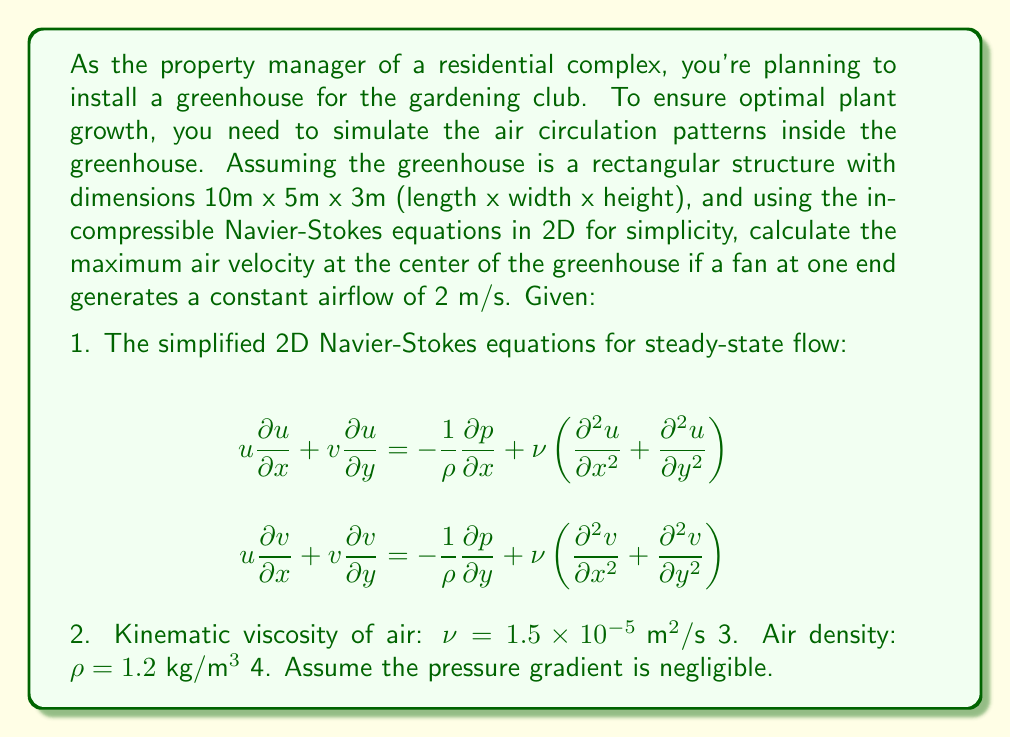What is the answer to this math problem? To solve this problem, we'll use a simplified approach based on the given Navier-Stokes equations and make some assumptions to estimate the maximum air velocity at the center of the greenhouse.

Step 1: Simplify the Navier-Stokes equations
Given that the pressure gradient is negligible, we can simplify the equations to:

$$u\frac{\partial u}{\partial x} + v\frac{\partial u}{\partial y} = \nu\left(\frac{\partial^2 u}{\partial x^2} + \frac{\partial^2 u}{\partial y^2}\right)$$
$$u\frac{\partial v}{\partial x} + v\frac{\partial v}{\partial y} = \nu\left(\frac{\partial^2 v}{\partial x^2} + \frac{\partial^2 v}{\partial y^2}\right)$$

Step 2: Assume a steady-state, one-dimensional flow
For simplicity, let's assume the flow is primarily in the x-direction and varies only with y. This allows us to further simplify the equations to:

$$\nu\frac{d^2 u}{dy^2} = 0$$

Step 3: Solve the simplified equation
The general solution to this equation is:

$$u(y) = Ay + B$$

Where A and B are constants determined by the boundary conditions.

Step 4: Apply boundary conditions
- At y = 0 (bottom of the greenhouse), u = 0 (no-slip condition)
- At y = 3m (top of the greenhouse), u = 2 m/s (fan-induced velocity)

Applying these conditions:
$$u(0) = 0 = B$$
$$u(3) = 2 = 3A + B = 3A$$

Therefore, A = 2/3 and B = 0

Step 5: Determine the velocity profile
The velocity profile is given by:

$$u(y) = \frac{2y}{3}$$

Step 6: Calculate the maximum velocity at the center
The center of the greenhouse is at y = 1.5m. Substituting this into our velocity profile equation:

$$u(1.5) = \frac{2(1.5)}{3} = 1 \text{ m/s}$$

Therefore, the maximum air velocity at the center of the greenhouse is 1 m/s.
Answer: The maximum air velocity at the center of the greenhouse is 1 m/s. 